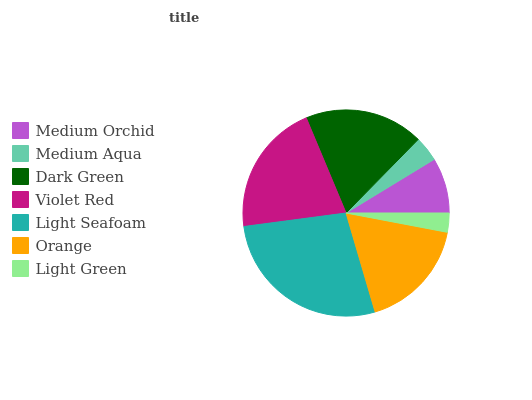Is Light Green the minimum?
Answer yes or no. Yes. Is Light Seafoam the maximum?
Answer yes or no. Yes. Is Medium Aqua the minimum?
Answer yes or no. No. Is Medium Aqua the maximum?
Answer yes or no. No. Is Medium Orchid greater than Medium Aqua?
Answer yes or no. Yes. Is Medium Aqua less than Medium Orchid?
Answer yes or no. Yes. Is Medium Aqua greater than Medium Orchid?
Answer yes or no. No. Is Medium Orchid less than Medium Aqua?
Answer yes or no. No. Is Orange the high median?
Answer yes or no. Yes. Is Orange the low median?
Answer yes or no. Yes. Is Light Green the high median?
Answer yes or no. No. Is Violet Red the low median?
Answer yes or no. No. 